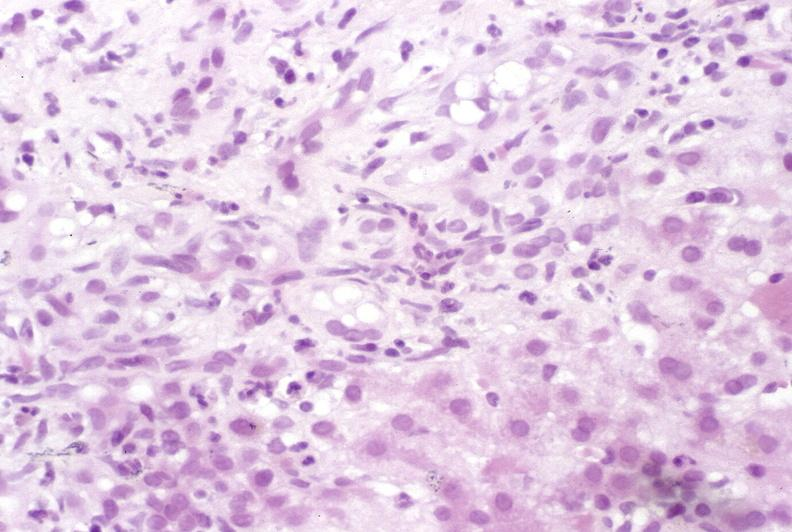s hepatobiliary present?
Answer the question using a single word or phrase. Yes 